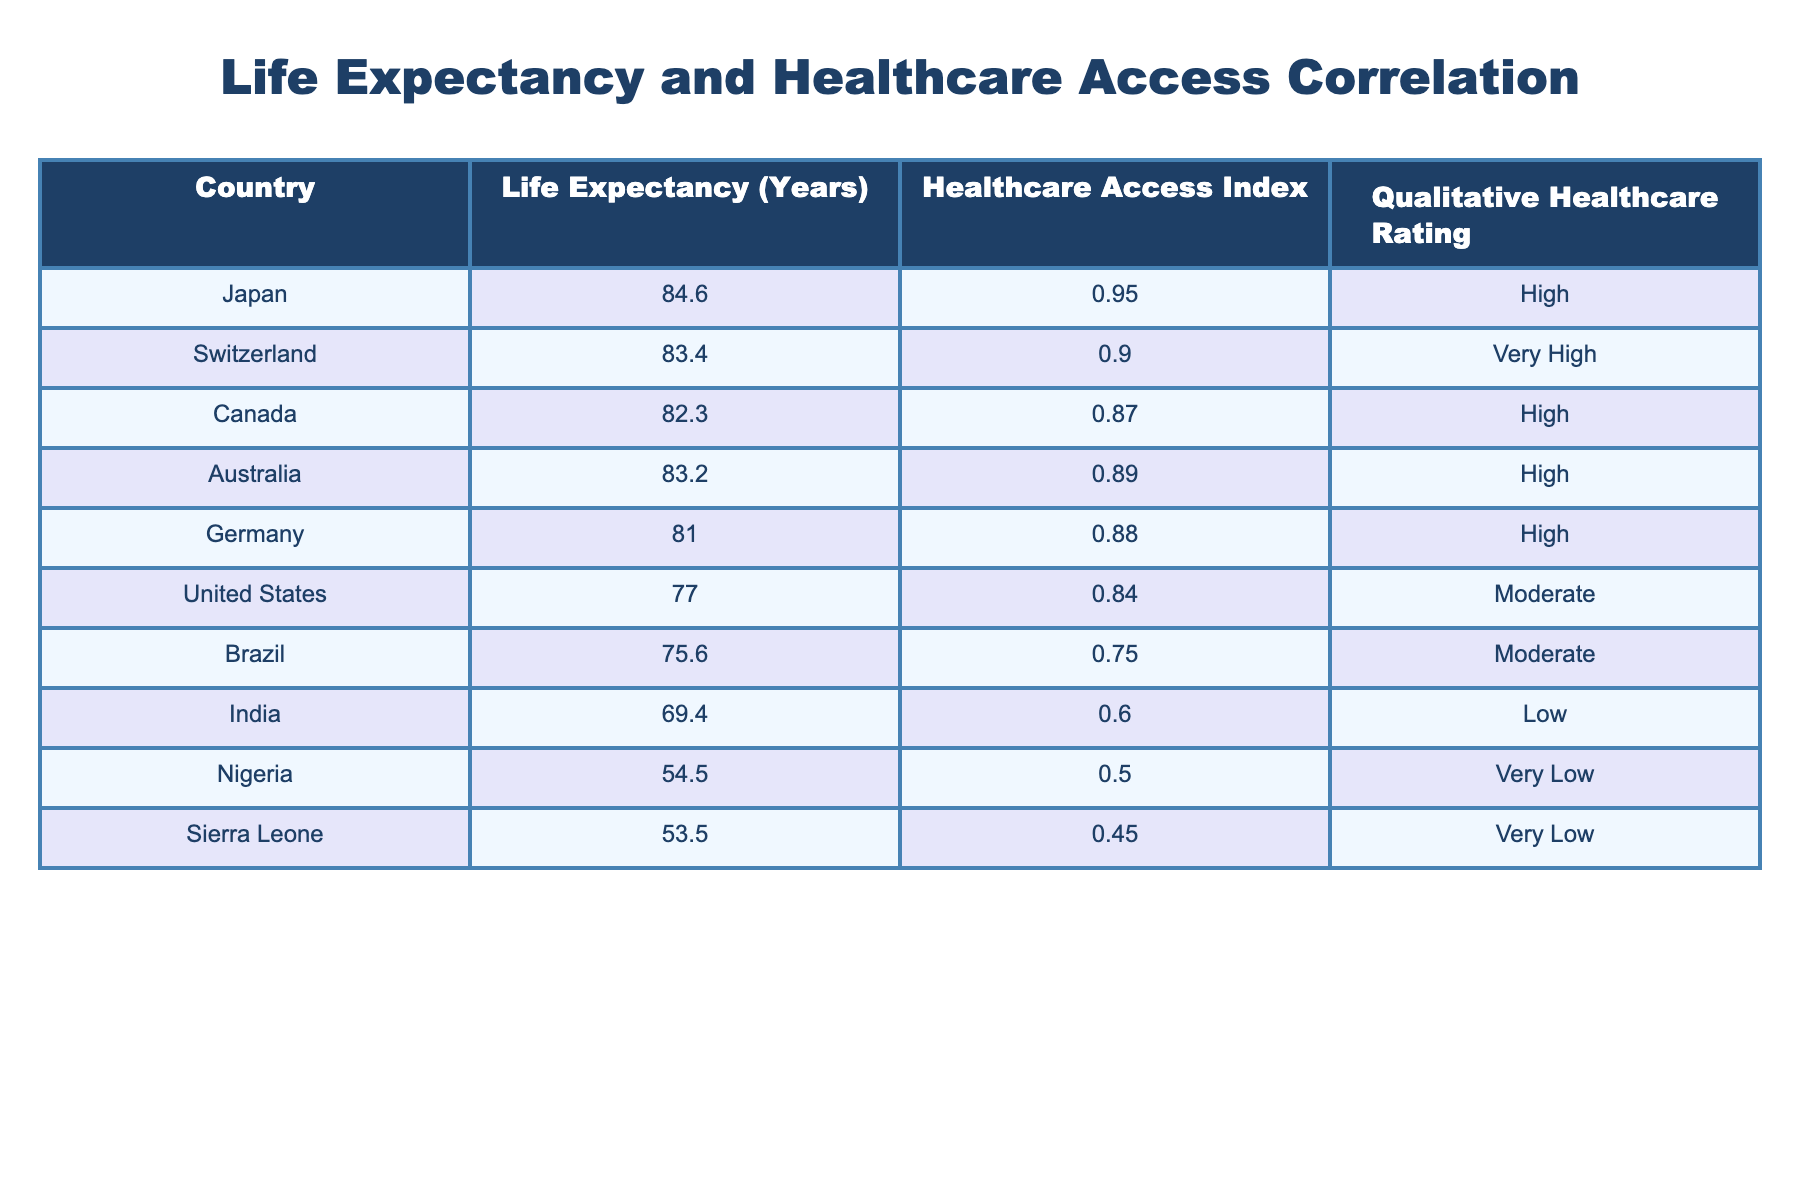What is the life expectancy of Japan? The table clearly lists Japan's life expectancy as 84.6 years.
Answer: 84.6 Which country has the highest Healthcare Access Index? The table shows that Japan has the highest Healthcare Access Index at 0.95.
Answer: Japan How many countries have a life expectancy above 80 years? The countries with a life expectancy above 80 years are Japan, Switzerland, Canada, and Australia, totaling 4 countries.
Answer: 4 What is the difference in life expectancy between the United States and Sierra Leone? The life expectancy of the United States is 77.0 years, while Sierra Leone's is 53.5 years. The difference is 77.0 - 53.5 = 23.5 years.
Answer: 23.5 Is the qualitative healthcare rating of Brazil high? According to the table, Brazil has a qualitative healthcare rating of moderate, which is not high.
Answer: No 